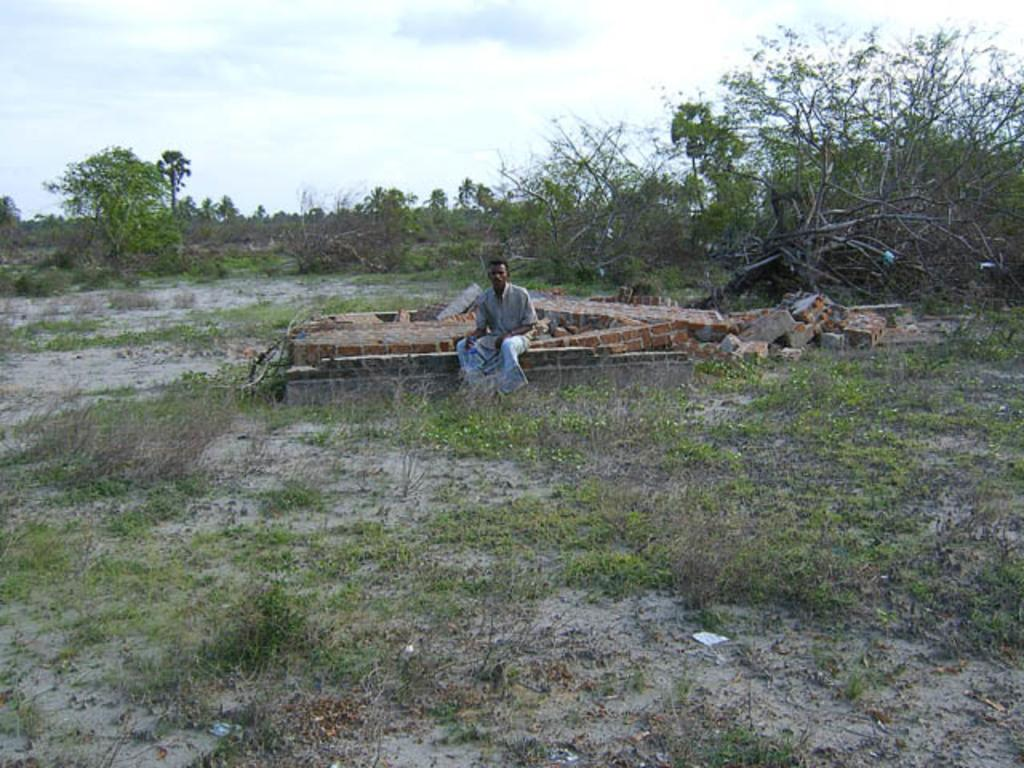What is the person in the image doing? The person is sitting on a fence in the image. What type of material can be seen in the image? Bricks are present in the image. What type of vegetation is visible in the image? Grass and trees are visible in the image. What part of the natural environment is visible in the image? The sky is visible in the image. Can you describe the possible setting of the image? The image may have been taken in a forest, given the presence of trees. How many pizzas can be seen in the image? There are no pizzas present in the image. What type of porter is assisting the person in the image? There is no porter present in the image, and the person is sitting on a fence, not being assisted. 